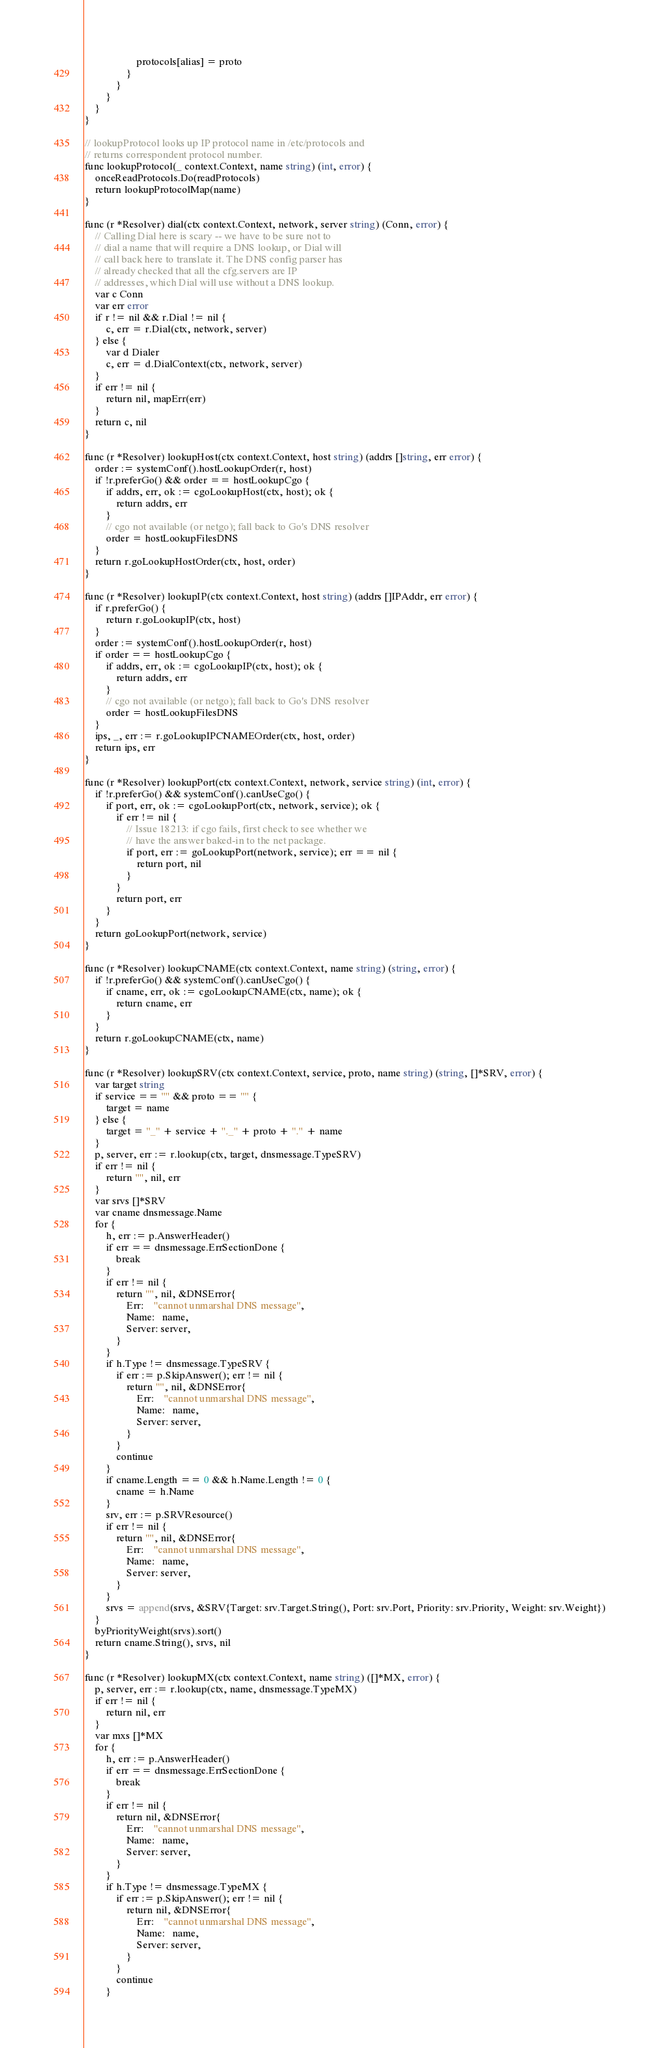<code> <loc_0><loc_0><loc_500><loc_500><_Go_>					protocols[alias] = proto
				}
			}
		}
	}
}

// lookupProtocol looks up IP protocol name in /etc/protocols and
// returns correspondent protocol number.
func lookupProtocol(_ context.Context, name string) (int, error) {
	onceReadProtocols.Do(readProtocols)
	return lookupProtocolMap(name)
}

func (r *Resolver) dial(ctx context.Context, network, server string) (Conn, error) {
	// Calling Dial here is scary -- we have to be sure not to
	// dial a name that will require a DNS lookup, or Dial will
	// call back here to translate it. The DNS config parser has
	// already checked that all the cfg.servers are IP
	// addresses, which Dial will use without a DNS lookup.
	var c Conn
	var err error
	if r != nil && r.Dial != nil {
		c, err = r.Dial(ctx, network, server)
	} else {
		var d Dialer
		c, err = d.DialContext(ctx, network, server)
	}
	if err != nil {
		return nil, mapErr(err)
	}
	return c, nil
}

func (r *Resolver) lookupHost(ctx context.Context, host string) (addrs []string, err error) {
	order := systemConf().hostLookupOrder(r, host)
	if !r.preferGo() && order == hostLookupCgo {
		if addrs, err, ok := cgoLookupHost(ctx, host); ok {
			return addrs, err
		}
		// cgo not available (or netgo); fall back to Go's DNS resolver
		order = hostLookupFilesDNS
	}
	return r.goLookupHostOrder(ctx, host, order)
}

func (r *Resolver) lookupIP(ctx context.Context, host string) (addrs []IPAddr, err error) {
	if r.preferGo() {
		return r.goLookupIP(ctx, host)
	}
	order := systemConf().hostLookupOrder(r, host)
	if order == hostLookupCgo {
		if addrs, err, ok := cgoLookupIP(ctx, host); ok {
			return addrs, err
		}
		// cgo not available (or netgo); fall back to Go's DNS resolver
		order = hostLookupFilesDNS
	}
	ips, _, err := r.goLookupIPCNAMEOrder(ctx, host, order)
	return ips, err
}

func (r *Resolver) lookupPort(ctx context.Context, network, service string) (int, error) {
	if !r.preferGo() && systemConf().canUseCgo() {
		if port, err, ok := cgoLookupPort(ctx, network, service); ok {
			if err != nil {
				// Issue 18213: if cgo fails, first check to see whether we
				// have the answer baked-in to the net package.
				if port, err := goLookupPort(network, service); err == nil {
					return port, nil
				}
			}
			return port, err
		}
	}
	return goLookupPort(network, service)
}

func (r *Resolver) lookupCNAME(ctx context.Context, name string) (string, error) {
	if !r.preferGo() && systemConf().canUseCgo() {
		if cname, err, ok := cgoLookupCNAME(ctx, name); ok {
			return cname, err
		}
	}
	return r.goLookupCNAME(ctx, name)
}

func (r *Resolver) lookupSRV(ctx context.Context, service, proto, name string) (string, []*SRV, error) {
	var target string
	if service == "" && proto == "" {
		target = name
	} else {
		target = "_" + service + "._" + proto + "." + name
	}
	p, server, err := r.lookup(ctx, target, dnsmessage.TypeSRV)
	if err != nil {
		return "", nil, err
	}
	var srvs []*SRV
	var cname dnsmessage.Name
	for {
		h, err := p.AnswerHeader()
		if err == dnsmessage.ErrSectionDone {
			break
		}
		if err != nil {
			return "", nil, &DNSError{
				Err:    "cannot unmarshal DNS message",
				Name:   name,
				Server: server,
			}
		}
		if h.Type != dnsmessage.TypeSRV {
			if err := p.SkipAnswer(); err != nil {
				return "", nil, &DNSError{
					Err:    "cannot unmarshal DNS message",
					Name:   name,
					Server: server,
				}
			}
			continue
		}
		if cname.Length == 0 && h.Name.Length != 0 {
			cname = h.Name
		}
		srv, err := p.SRVResource()
		if err != nil {
			return "", nil, &DNSError{
				Err:    "cannot unmarshal DNS message",
				Name:   name,
				Server: server,
			}
		}
		srvs = append(srvs, &SRV{Target: srv.Target.String(), Port: srv.Port, Priority: srv.Priority, Weight: srv.Weight})
	}
	byPriorityWeight(srvs).sort()
	return cname.String(), srvs, nil
}

func (r *Resolver) lookupMX(ctx context.Context, name string) ([]*MX, error) {
	p, server, err := r.lookup(ctx, name, dnsmessage.TypeMX)
	if err != nil {
		return nil, err
	}
	var mxs []*MX
	for {
		h, err := p.AnswerHeader()
		if err == dnsmessage.ErrSectionDone {
			break
		}
		if err != nil {
			return nil, &DNSError{
				Err:    "cannot unmarshal DNS message",
				Name:   name,
				Server: server,
			}
		}
		if h.Type != dnsmessage.TypeMX {
			if err := p.SkipAnswer(); err != nil {
				return nil, &DNSError{
					Err:    "cannot unmarshal DNS message",
					Name:   name,
					Server: server,
				}
			}
			continue
		}</code> 